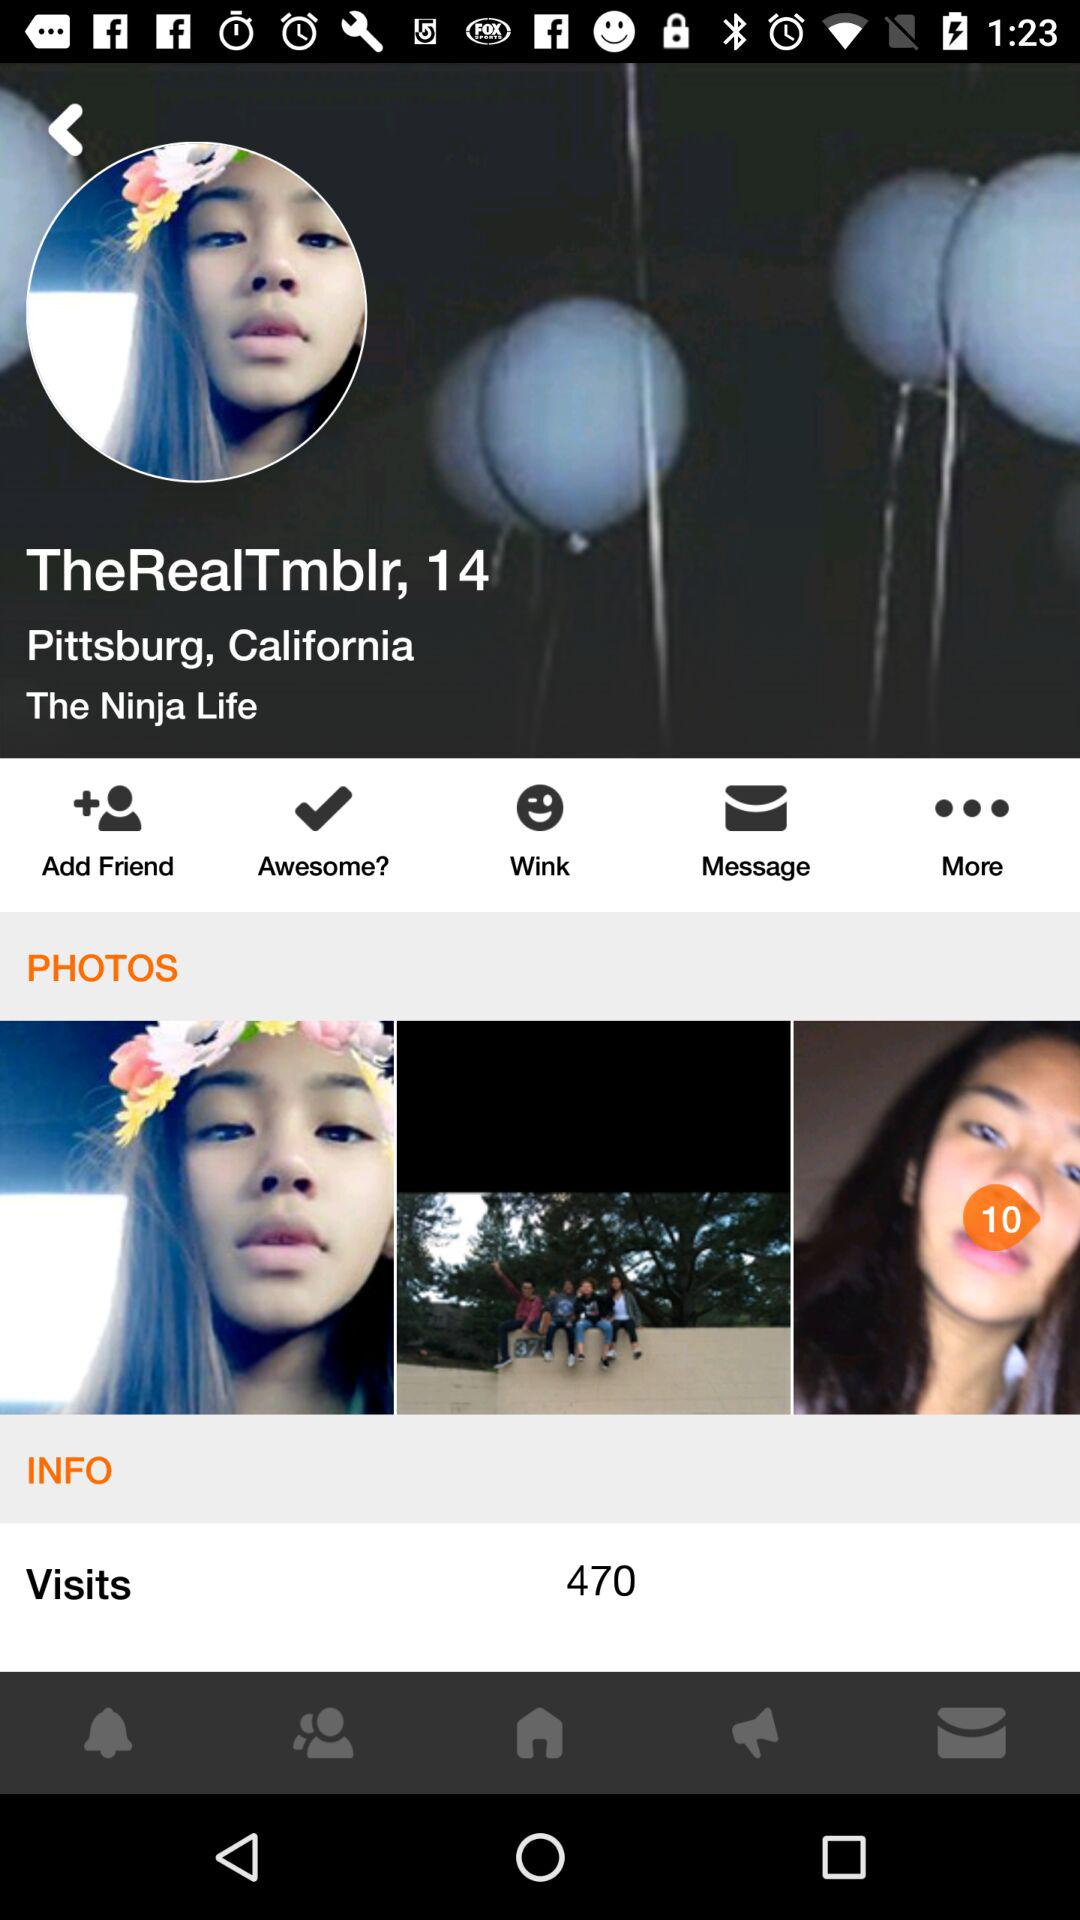What is the age of the user? The age of the user is 14 years. 